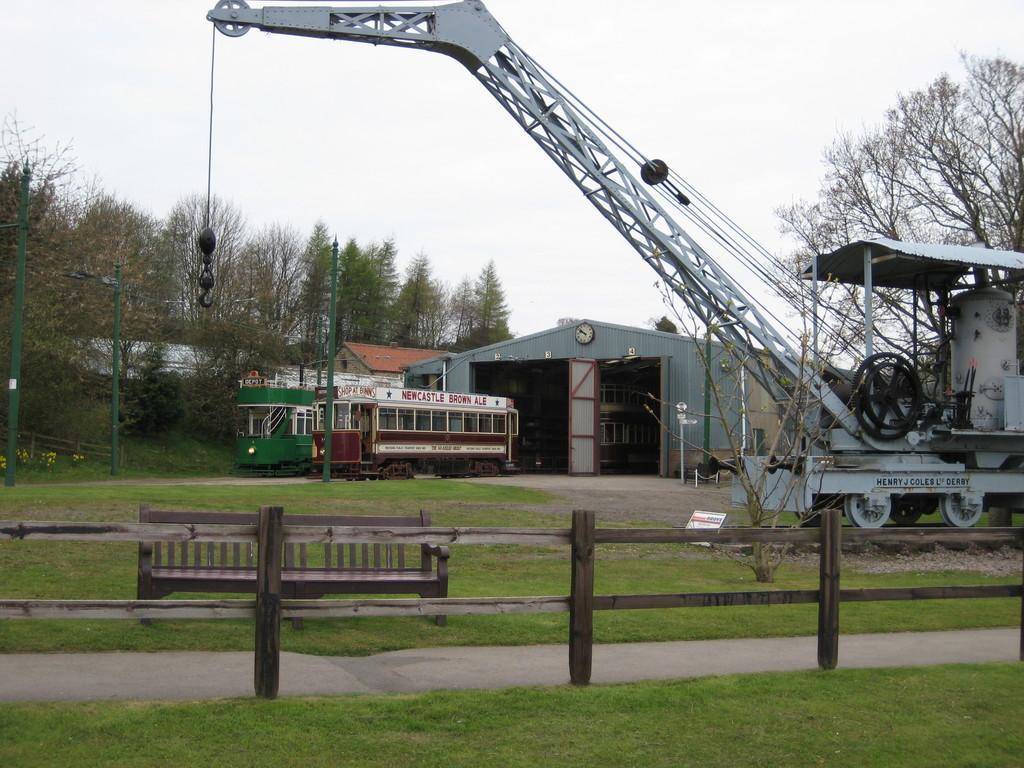Can you describe this image briefly? There is a wooden boundary and grassland in the foreground area of the image, there are house structure, trees, a vehicle, it seems like crane and the sky in the background area. 